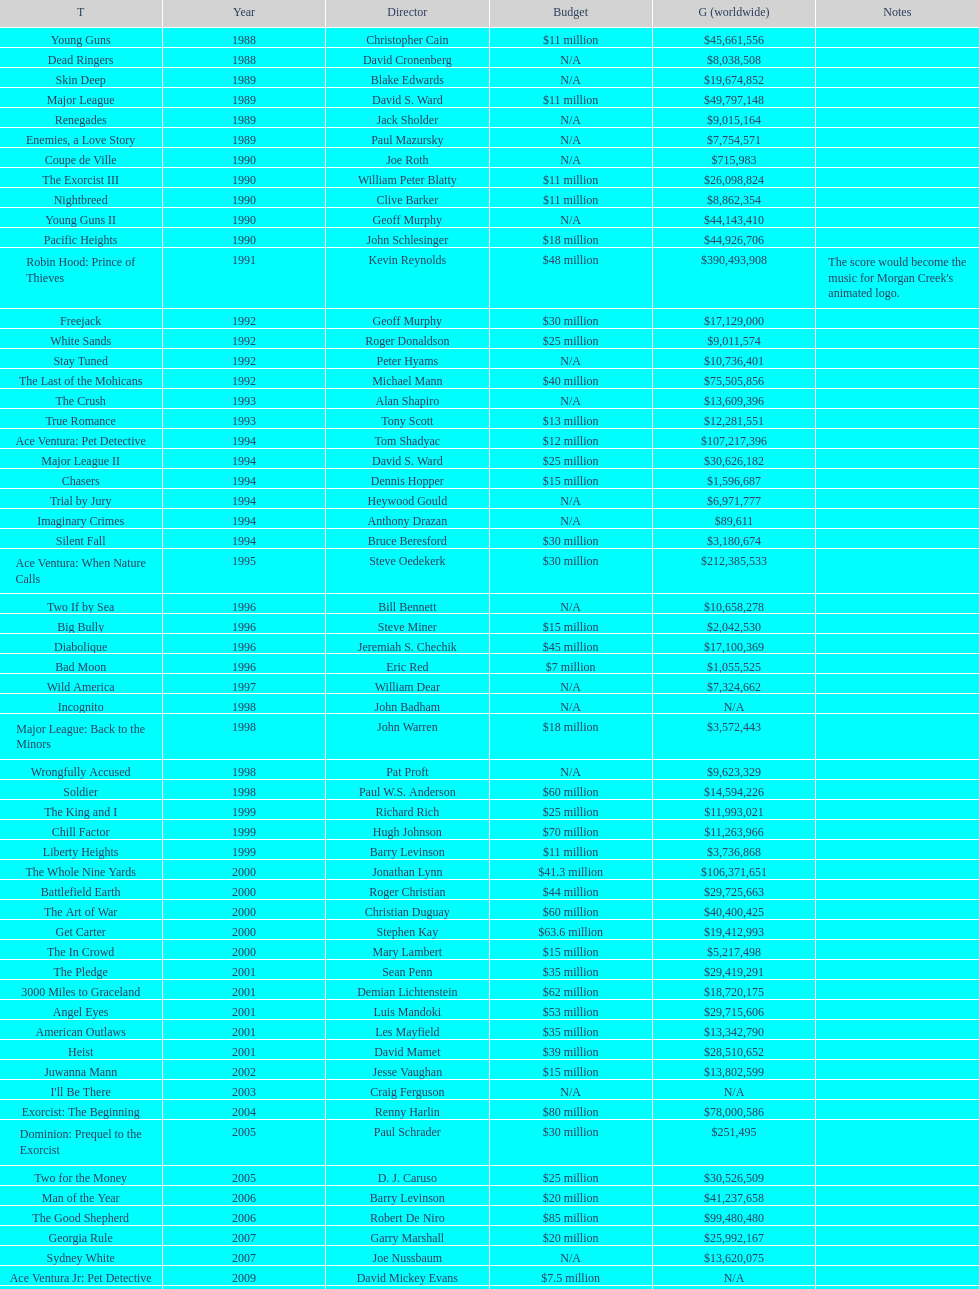Which film had a higher budget, ace ventura: when nature calls, or major league: back to the minors? Ace Ventura: When Nature Calls. 